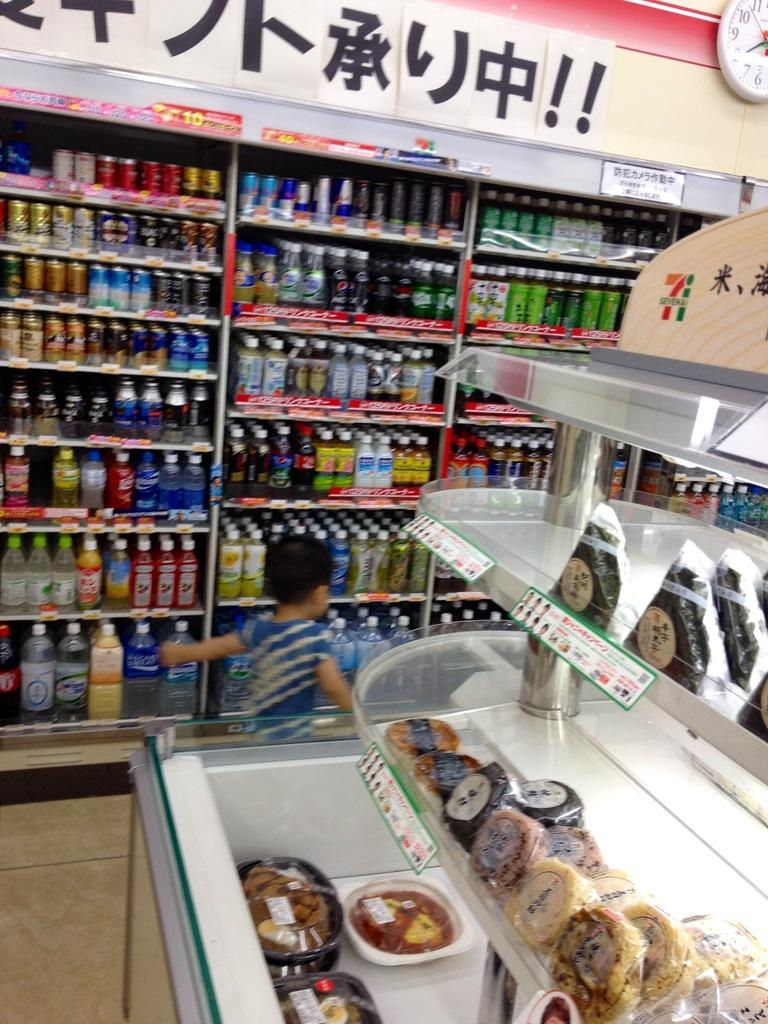<image>
Share a concise interpretation of the image provided. An Asian store with an analog clock in the corner and foreign characters on the wall. 